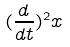<formula> <loc_0><loc_0><loc_500><loc_500>( \frac { d } { d t } ) ^ { 2 } x</formula> 